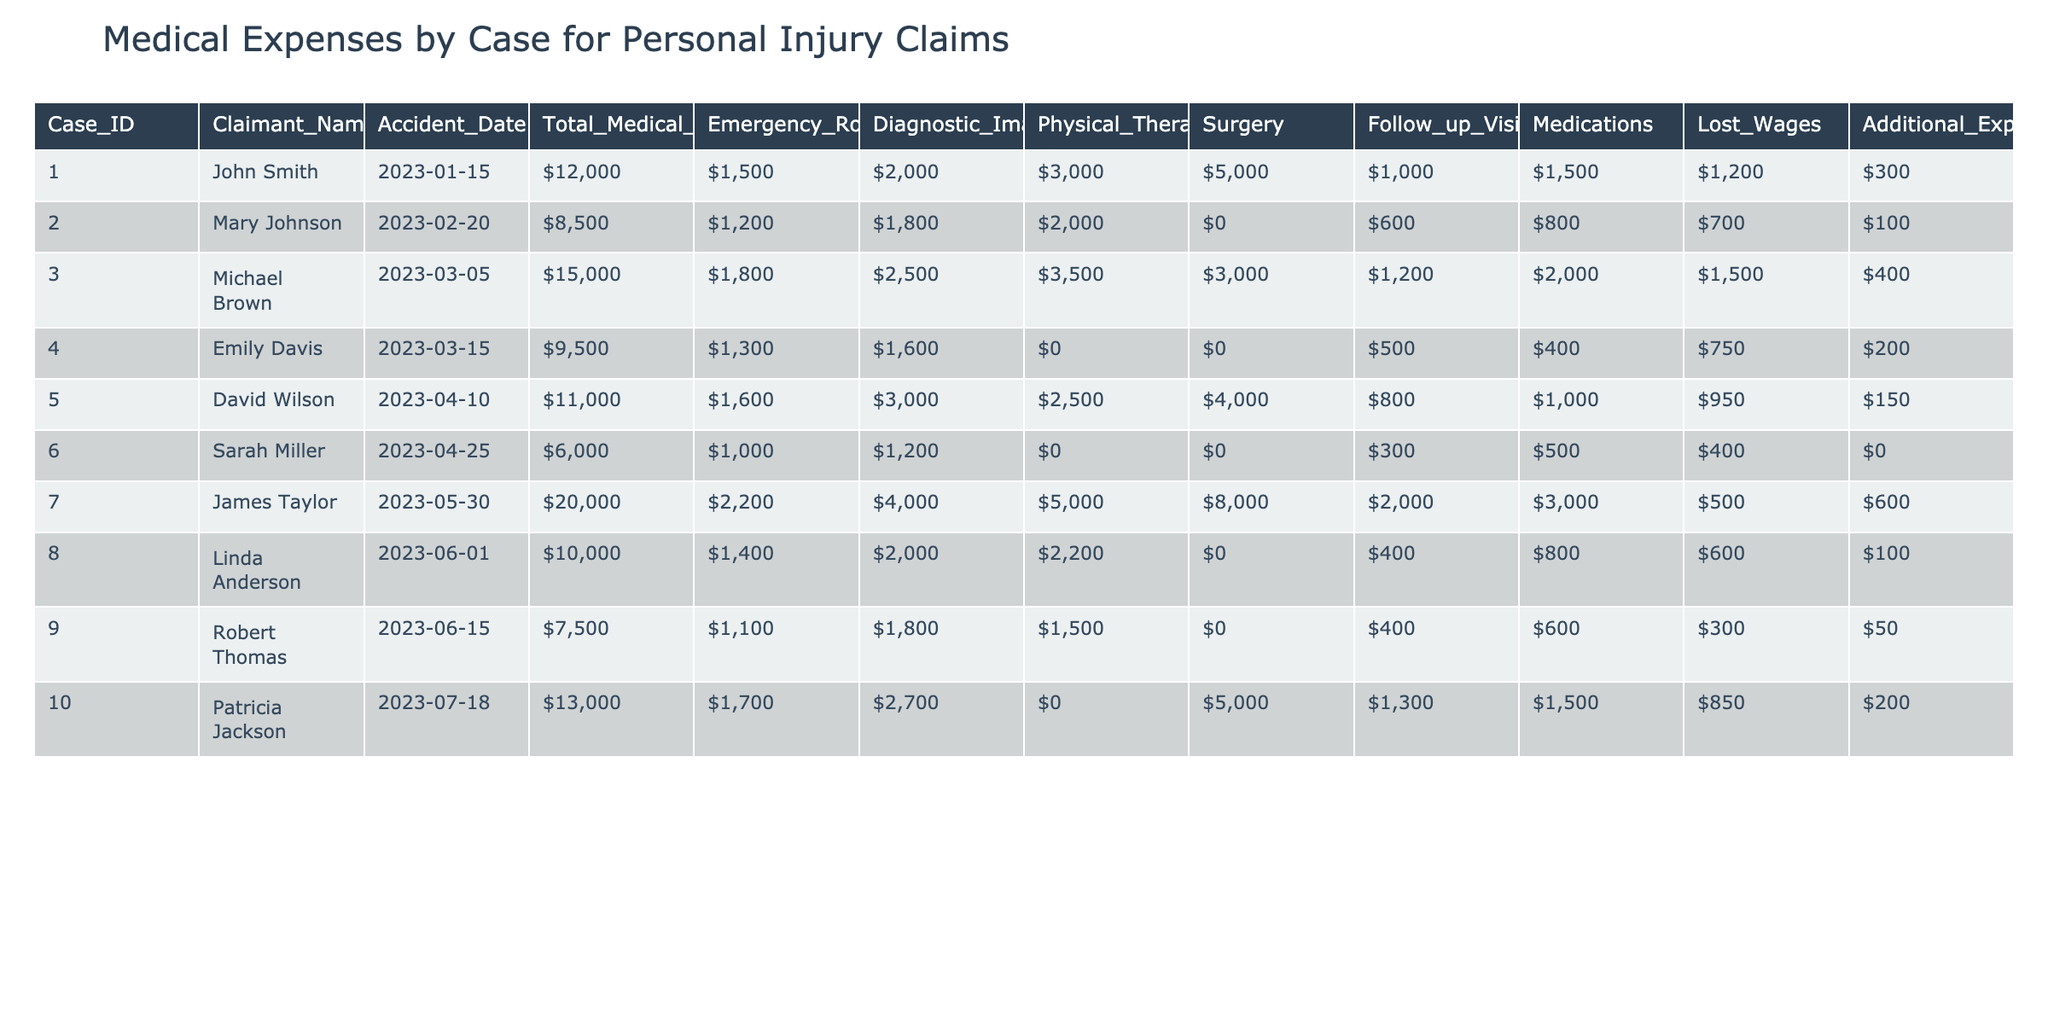What is the total medical expenses for John Smith's case? Looking at the table, find the row with John Smith's name, which corresponds to Case ID 001. The total medical expenses listed for this case is $12,000.
Answer: $12,000 Which claimant had the highest total medical expenses? Review the Total Medical Expenses column to find the maximum value. The highest amount is $20,000, which corresponds to James Taylor's case (Case ID 007).
Answer: James Taylor What is the average cost for emergency room visits across all cases? Sum the Emergency Room Visit values for all claimants: ($1,500 + $1,200 + $1,800 + $1,300 + $1,600 + $1,000 + $2,200 + $1,400 + $1,100 + $1,700) = $13,400. Divide this sum by the number of cases, which is 10: $13,400 / 10 = $1,340.
Answer: $1,340 Did any case involve surgery costs that exceeded $5,000? Check the Surgery column for values above $5,000. The only entry that meets this criterion is Case ID 007 (James Taylor), which has a surgery cost of $8,000.
Answer: Yes What is the difference in total medical expenses between the highest and lowest cases? First, identify the highest total medical expenses, which is $20,000 (James Taylor), and the lowest, which is $6,000 (Sarah Miller). The difference is calculated as $20,000 - $6,000 = $14,000.
Answer: $14,000 What percentage of total medical expenses does follow-up visits represent for Patricia Jackson? Review Patricia Jackson's row for Follow-up Visits, which is $850, and Total Medical Expenses, which is $13,000. Calculate the percentage: ($850 / $13,000) * 100 = 6.54%.
Answer: 6.54% Which claimant had more than $5,000 in medications, and what is their total medical expense? Look at the Medications column for values greater than $5,000. None of the claimants exceed this threshold; hence we check claimants under $5,000. The highest total medical expense is $15,000 (Michael Brown), with medication costs of $2,000.
Answer: No claimant had more than $5,000 in medications Is it true that Emily Davis incurred only follow-up visit costs? From Emily Davis's row, the values for follow-up visits is $750 while other costs like Emergency Room Visits ($1,300) and Medications ($400) add up to more than the follow-up visits only. Therefore, this statement is false.
Answer: False How many claimants had zero costs for physical therapy? Check the Physical Therapy column and count the number of rows with a value of $0. There are two claimants (Emily Davis and Sarah Miller) with zero physical therapy costs.
Answer: 2 What is the total loss in wages for all claimants combined? Sum the Lost Wages for each claimant: ($1,200 + $700 + $1,500 + $750 + $950 + $400 + $500 + $600 + $300 + $850) = $8,500.
Answer: $8,500 